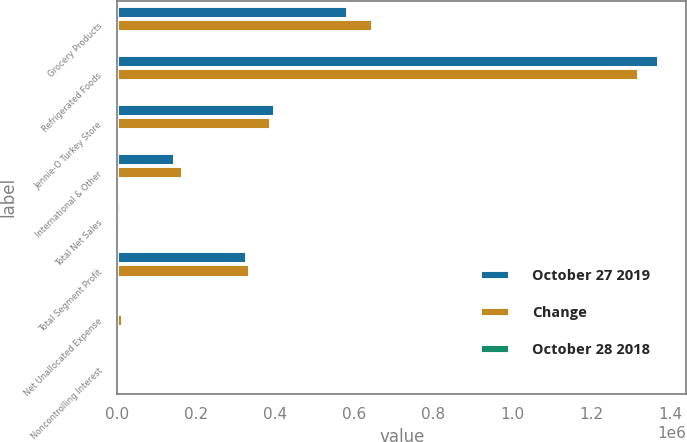Convert chart to OTSL. <chart><loc_0><loc_0><loc_500><loc_500><stacked_bar_chart><ecel><fcel>Grocery Products<fcel>Refrigerated Foods<fcel>Jennie-O Turkey Store<fcel>International & Other<fcel>Total Net Sales<fcel>Total Segment Profit<fcel>Net Unallocated Expense<fcel>Noncontrolling Interest<nl><fcel>October 27 2019<fcel>584085<fcel>1.37301e+06<fcel>398512<fcel>145907<fcel>10426<fcel>328696<fcel>5065<fcel>63<nl><fcel>Change<fcel>648244<fcel>1.32178e+06<fcel>388278<fcel>166391<fcel>10426<fcel>337201<fcel>15787<fcel>90<nl><fcel>October 28 2018<fcel>9.9<fcel>3.9<fcel>2.6<fcel>12.3<fcel>0.9<fcel>2.5<fcel>67.9<fcel>30<nl></chart> 